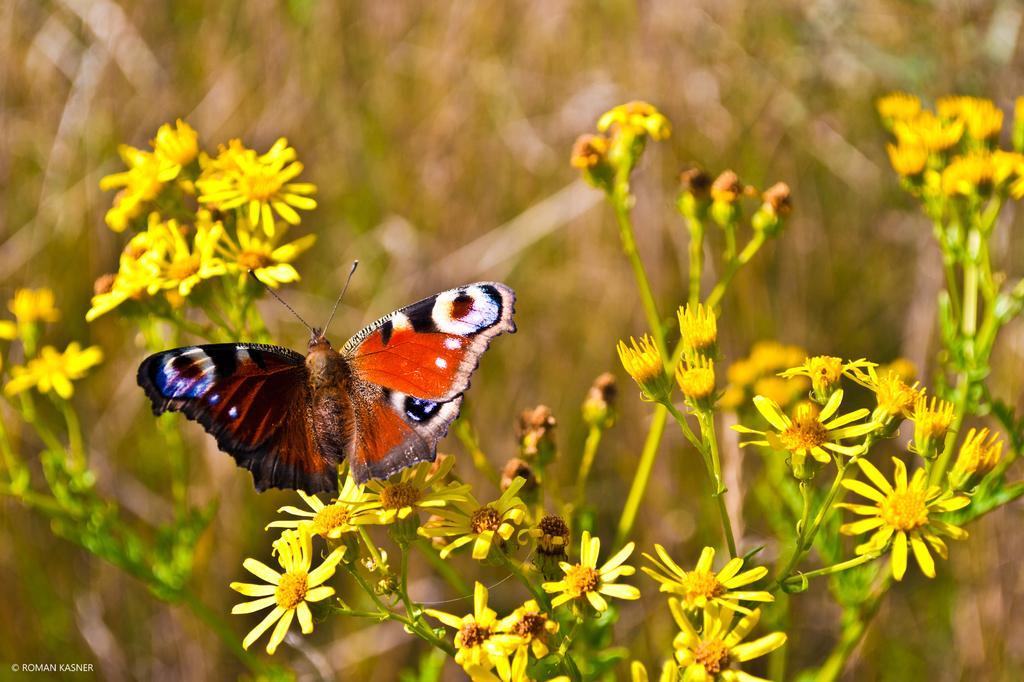Could you give a brief overview of what you see in this image? In the foreground of this image, there is a butterfly and few flowers and buds to the plant and the background image is blur. 